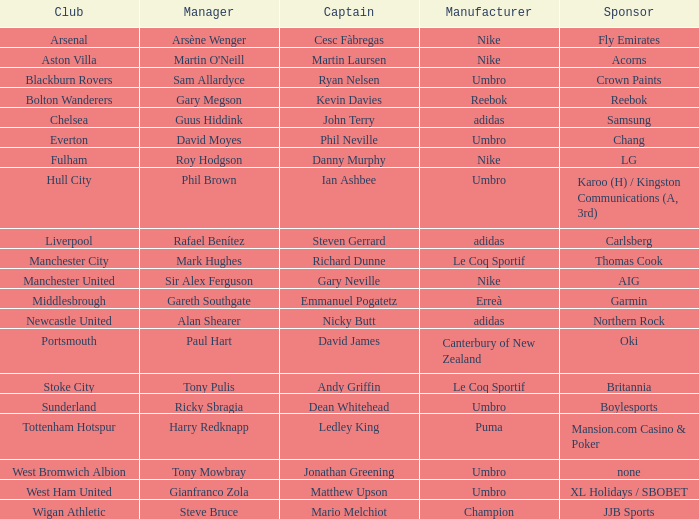Would you mind parsing the complete table? {'header': ['Club', 'Manager', 'Captain', 'Manufacturer', 'Sponsor'], 'rows': [['Arsenal', 'Arsène Wenger', 'Cesc Fàbregas', 'Nike', 'Fly Emirates'], ['Aston Villa', "Martin O'Neill", 'Martin Laursen', 'Nike', 'Acorns'], ['Blackburn Rovers', 'Sam Allardyce', 'Ryan Nelsen', 'Umbro', 'Crown Paints'], ['Bolton Wanderers', 'Gary Megson', 'Kevin Davies', 'Reebok', 'Reebok'], ['Chelsea', 'Guus Hiddink', 'John Terry', 'adidas', 'Samsung'], ['Everton', 'David Moyes', 'Phil Neville', 'Umbro', 'Chang'], ['Fulham', 'Roy Hodgson', 'Danny Murphy', 'Nike', 'LG'], ['Hull City', 'Phil Brown', 'Ian Ashbee', 'Umbro', 'Karoo (H) / Kingston Communications (A, 3rd)'], ['Liverpool', 'Rafael Benítez', 'Steven Gerrard', 'adidas', 'Carlsberg'], ['Manchester City', 'Mark Hughes', 'Richard Dunne', 'Le Coq Sportif', 'Thomas Cook'], ['Manchester United', 'Sir Alex Ferguson', 'Gary Neville', 'Nike', 'AIG'], ['Middlesbrough', 'Gareth Southgate', 'Emmanuel Pogatetz', 'Erreà', 'Garmin'], ['Newcastle United', 'Alan Shearer', 'Nicky Butt', 'adidas', 'Northern Rock'], ['Portsmouth', 'Paul Hart', 'David James', 'Canterbury of New Zealand', 'Oki'], ['Stoke City', 'Tony Pulis', 'Andy Griffin', 'Le Coq Sportif', 'Britannia'], ['Sunderland', 'Ricky Sbragia', 'Dean Whitehead', 'Umbro', 'Boylesports'], ['Tottenham Hotspur', 'Harry Redknapp', 'Ledley King', 'Puma', 'Mansion.com Casino & Poker'], ['West Bromwich Albion', 'Tony Mowbray', 'Jonathan Greening', 'Umbro', 'none'], ['West Ham United', 'Gianfranco Zola', 'Matthew Upson', 'Umbro', 'XL Holidays / SBOBET'], ['Wigan Athletic', 'Steve Bruce', 'Mario Melchiot', 'Champion', 'JJB Sports']]} Which manchester united captain has nike sponsorship? Gary Neville. 